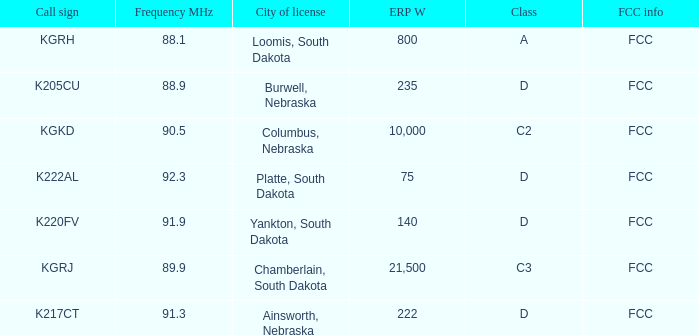What is the total frequency mhz of the kgrj call sign, which has an erp w greater than 21,500? 0.0. 